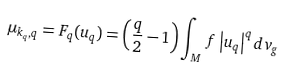<formula> <loc_0><loc_0><loc_500><loc_500>\mu _ { k _ { q } , q } = F _ { q } ( u _ { q } ) = \left ( \frac { q } { 2 } - 1 \right ) \int _ { M } f \left | u _ { q } \right | ^ { q } d v _ { g }</formula> 